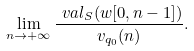<formula> <loc_0><loc_0><loc_500><loc_500>\lim _ { n \to + \infty } \frac { \ v a l _ { S } ( w [ 0 , n - 1 ] ) } { v _ { q _ { 0 } } ( n ) } .</formula> 